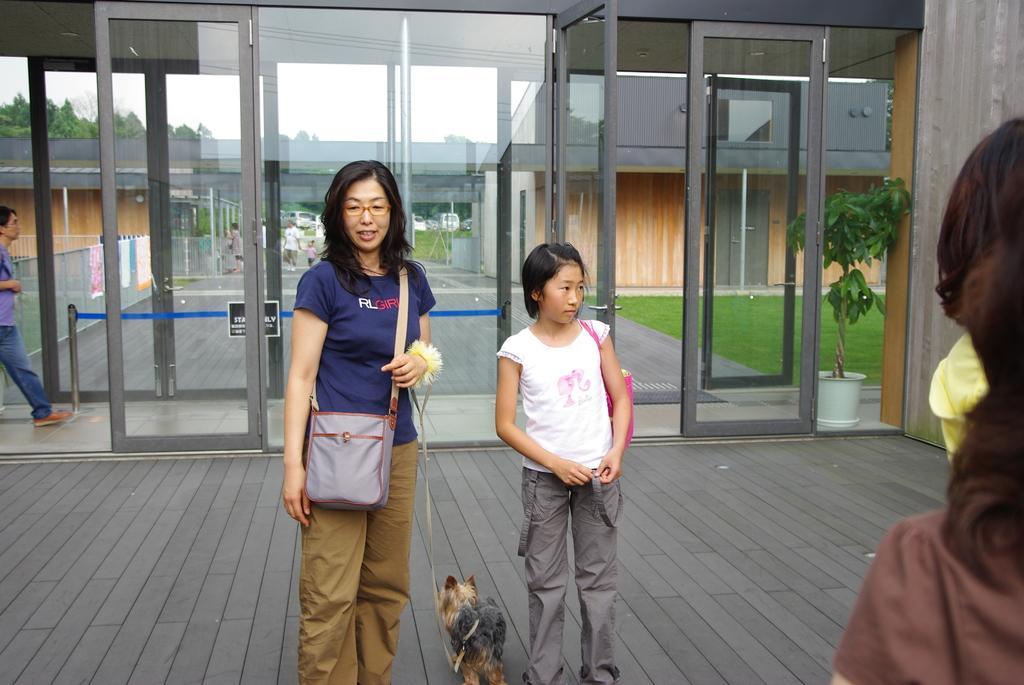Please provide a concise description of this image. In this image I see 2 women and I see that both of them are standing and holding their bags and there is a dog over here and I also there is a man over here and there is a plant and the grass. 